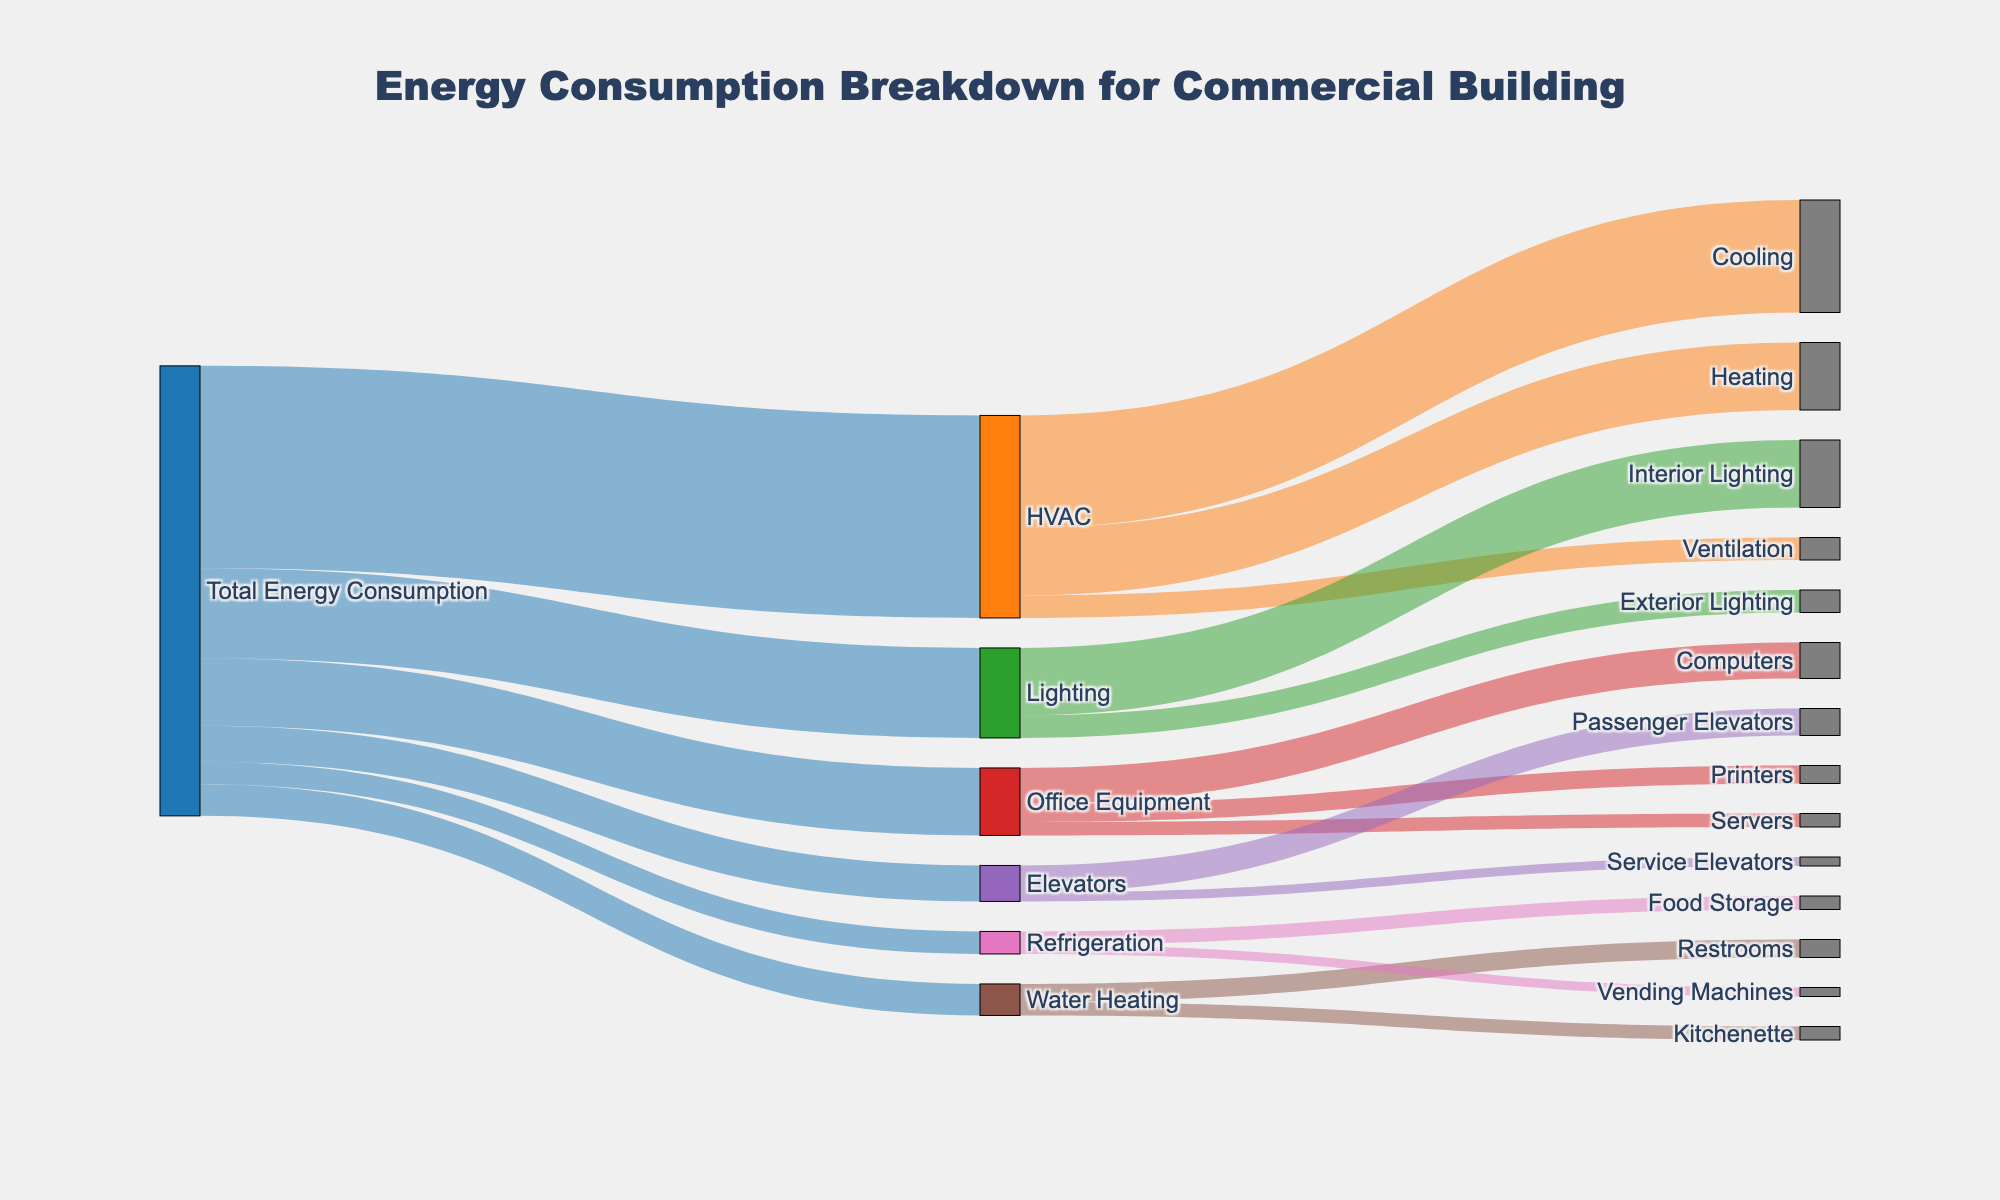What is the largest energy consumer in the building? The largest energy consumer in the building can be identified by looking at the segment with the highest value stemming directly from "Total Energy Consumption". HVAC, with a value of 45, is the largest energy consumer.
Answer: HVAC Which system under HVAC consumes more energy, Cooling or Heating? To determine which consumes more energy, we compare the values for Cooling and Heating. Cooling has a value of 25, while Heating has a value of 15. Therefore, Cooling consumes more energy.
Answer: Cooling What is the total energy consumption attributed to Office Equipment? The total energy consumption for Office Equipment can be found by summing the values for Computers, Printers, and Servers. The values are 8, 4, and 3 respectively. Therefore, the total is 8 + 4 + 3 = 15.
Answer: 15 How does the energy consumption for Elevators compare to Refrigeration? From the figure, Elevators have a value of 8, and Refrigeration has a value of 5. Therefore, Elevators consume more energy than Refrigeration.
Answer: Elevators What percentage of the total energy is used for Water Heating? To find the percentage, we divide the energy used for Water Heating by the Total Energy Consumption and multiply by 100. Water Heating has a value of 7, and Total Energy Consumption is 100. Thus, (7 / 100) * 100 = 7%.
Answer: 7% What is the combined energy consumption for Passenger Elevators and Service Elevators? Passenger Elevators have a value of 6, and Service Elevators have a value of 2. Adding these together gives 6 + 2 = 8.
Answer: 8 Which specific lighting type consumes the most energy? The two lighting types are Interior Lighting with a value of 15, and Exterior Lighting with a value of 5. Interior Lighting consumes the most energy.
Answer: Interior Lighting How much more energy does Interior Lighting consume compared to Exterior Lighting? Interior Lighting has a value of 15, and Exterior Lighting has a value of 5. The difference is 15 - 5 = 10.
Answer: 10 What is the total energy contribution of heating and ventilation combined within HVAC? Heating contributes 15 and Ventilation contributes 5. Their combined contribution is 15 + 5 = 20.
Answer: 20 